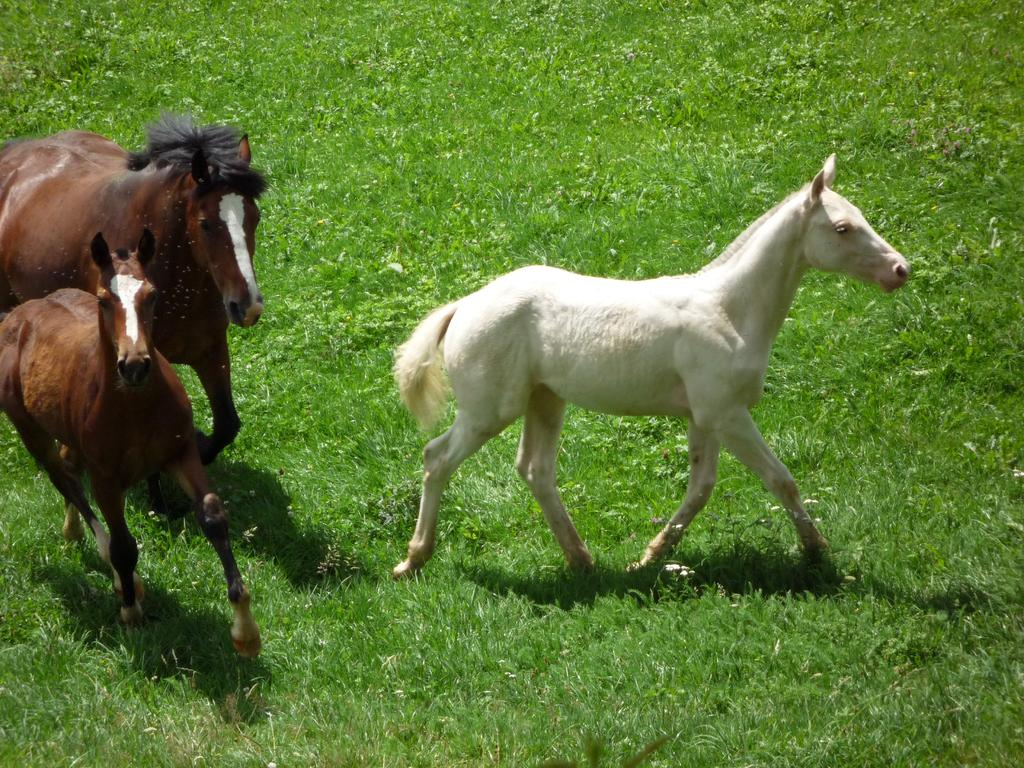What animals are in the center of the image? There are three horses in the center of the image. What type of vegetation is at the bottom of the image? There is grass at the bottom of the image. What type of bird can be heard laughing in the image? There is no bird or sound present in the image, so it is not possible to determine what type of bird might be heard laughing. 